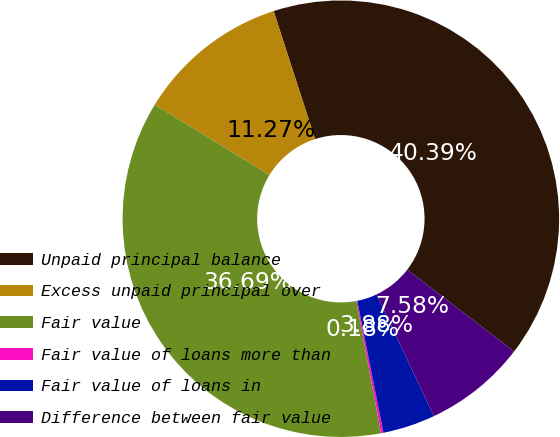Convert chart. <chart><loc_0><loc_0><loc_500><loc_500><pie_chart><fcel>Unpaid principal balance<fcel>Excess unpaid principal over<fcel>Fair value<fcel>Fair value of loans more than<fcel>Fair value of loans in<fcel>Difference between fair value<nl><fcel>40.39%<fcel>11.27%<fcel>36.69%<fcel>0.18%<fcel>3.88%<fcel>7.58%<nl></chart> 